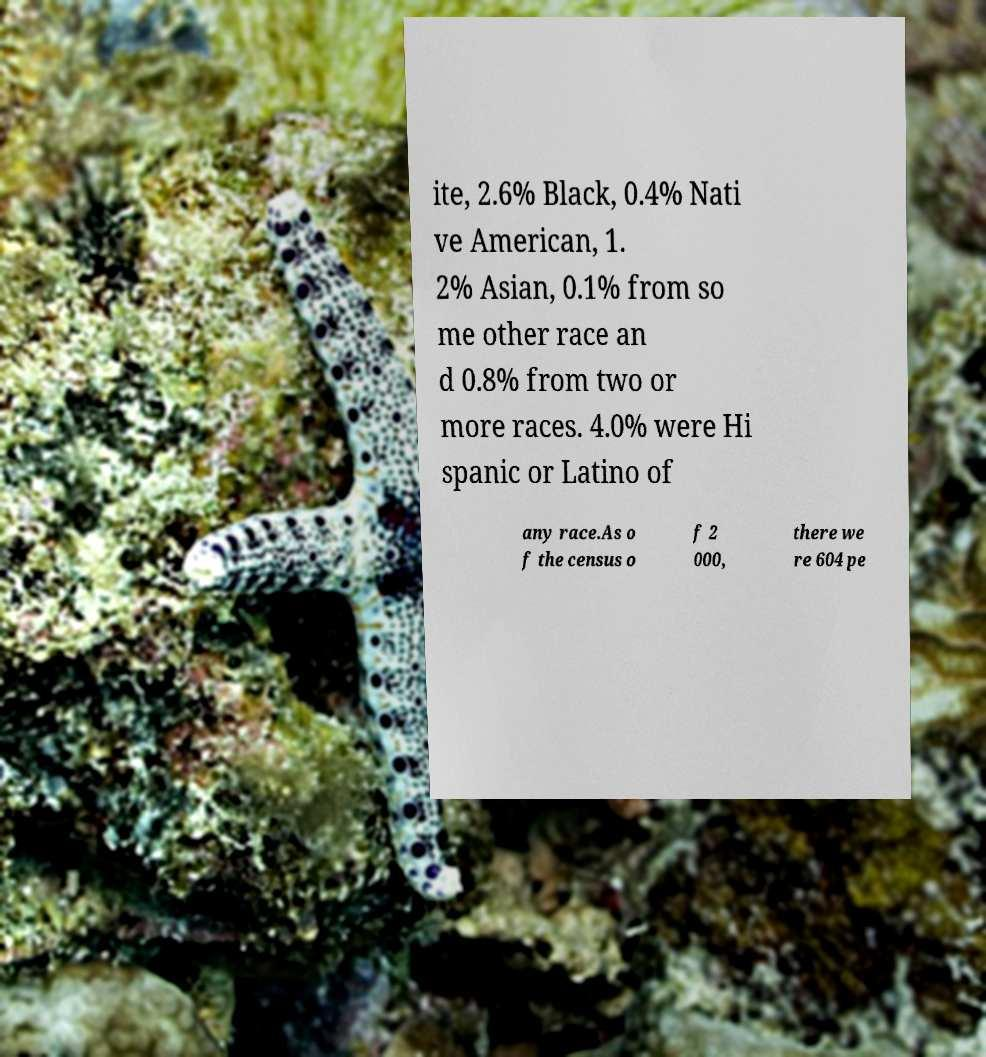Please identify and transcribe the text found in this image. ite, 2.6% Black, 0.4% Nati ve American, 1. 2% Asian, 0.1% from so me other race an d 0.8% from two or more races. 4.0% were Hi spanic or Latino of any race.As o f the census o f 2 000, there we re 604 pe 